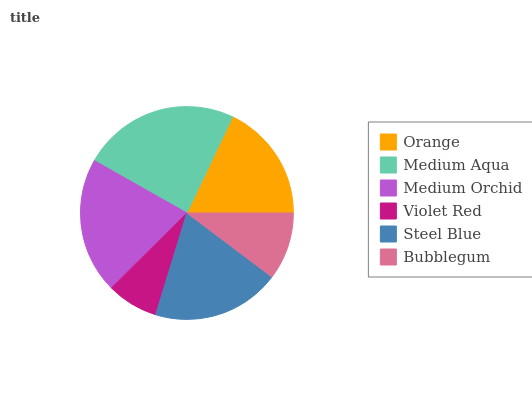Is Violet Red the minimum?
Answer yes or no. Yes. Is Medium Aqua the maximum?
Answer yes or no. Yes. Is Medium Orchid the minimum?
Answer yes or no. No. Is Medium Orchid the maximum?
Answer yes or no. No. Is Medium Aqua greater than Medium Orchid?
Answer yes or no. Yes. Is Medium Orchid less than Medium Aqua?
Answer yes or no. Yes. Is Medium Orchid greater than Medium Aqua?
Answer yes or no. No. Is Medium Aqua less than Medium Orchid?
Answer yes or no. No. Is Steel Blue the high median?
Answer yes or no. Yes. Is Orange the low median?
Answer yes or no. Yes. Is Medium Orchid the high median?
Answer yes or no. No. Is Violet Red the low median?
Answer yes or no. No. 